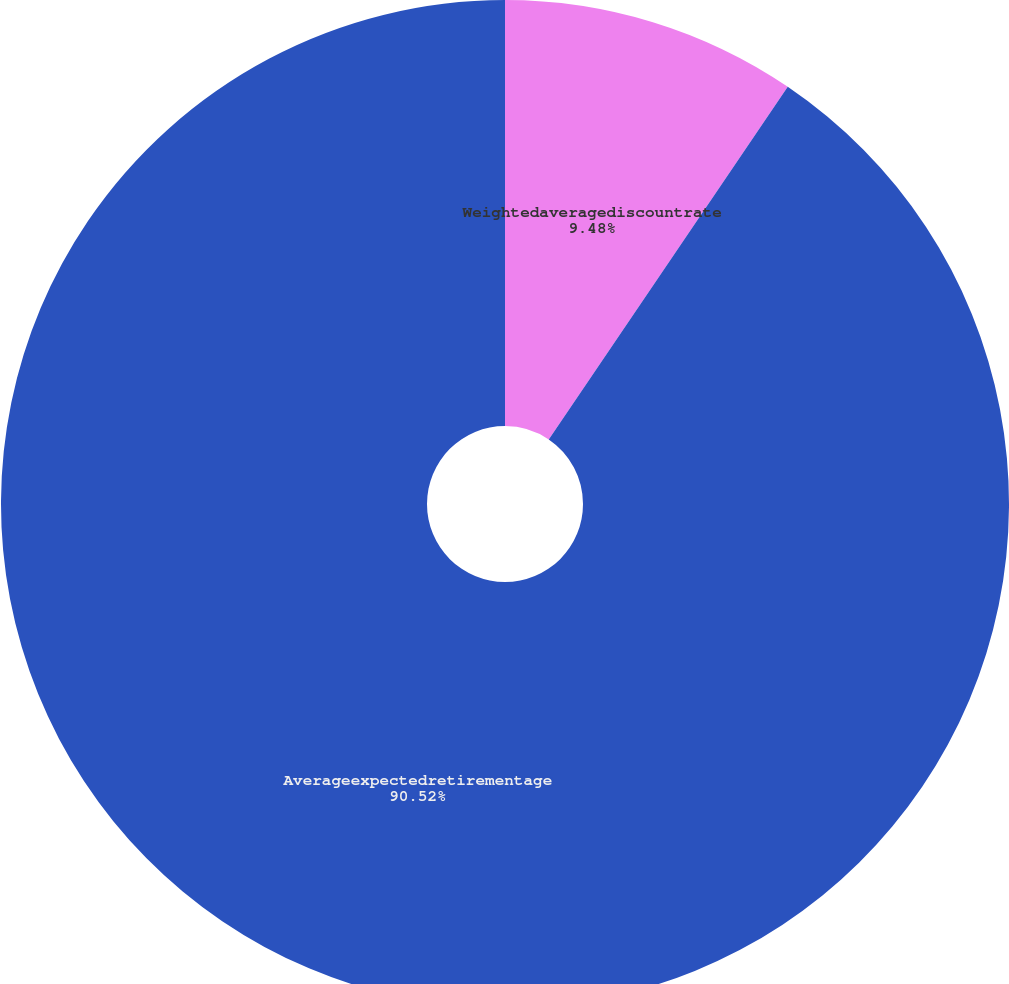Convert chart. <chart><loc_0><loc_0><loc_500><loc_500><pie_chart><fcel>Weightedaveragediscountrate<fcel>Averageexpectedretirementage<nl><fcel>9.48%<fcel>90.52%<nl></chart> 